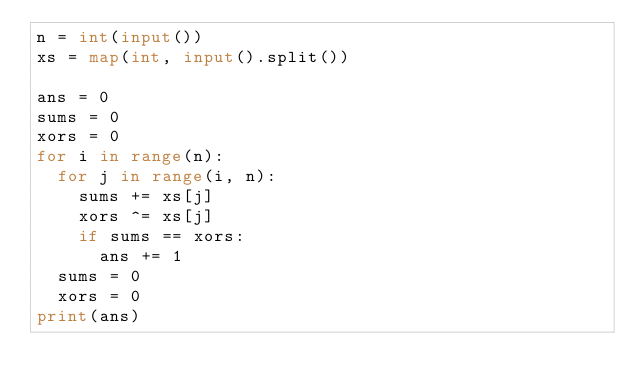Convert code to text. <code><loc_0><loc_0><loc_500><loc_500><_Python_>n = int(input())
xs = map(int, input().split())

ans = 0
sums = 0
xors = 0
for i in range(n):
  for j in range(i, n):
    sums += xs[j]
    xors ^= xs[j]
    if sums == xors:
      ans += 1
  sums = 0
  xors = 0
print(ans)</code> 